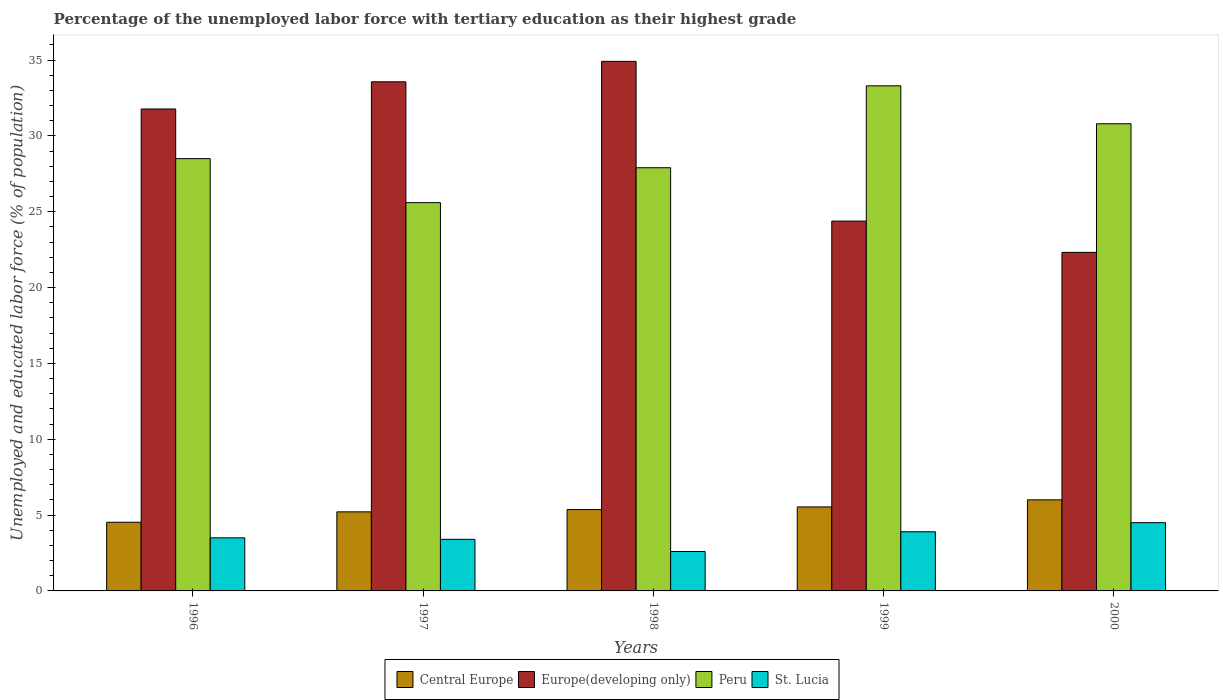In how many cases, is the number of bars for a given year not equal to the number of legend labels?
Your answer should be very brief. 0. What is the percentage of the unemployed labor force with tertiary education in Peru in 1998?
Your answer should be compact. 27.9. Across all years, what is the maximum percentage of the unemployed labor force with tertiary education in Central Europe?
Your answer should be compact. 6.01. Across all years, what is the minimum percentage of the unemployed labor force with tertiary education in Central Europe?
Offer a terse response. 4.53. In which year was the percentage of the unemployed labor force with tertiary education in Central Europe maximum?
Your answer should be compact. 2000. In which year was the percentage of the unemployed labor force with tertiary education in Peru minimum?
Your response must be concise. 1997. What is the total percentage of the unemployed labor force with tertiary education in Europe(developing only) in the graph?
Make the answer very short. 146.96. What is the difference between the percentage of the unemployed labor force with tertiary education in Europe(developing only) in 1996 and that in 1998?
Ensure brevity in your answer.  -3.14. What is the difference between the percentage of the unemployed labor force with tertiary education in Central Europe in 1997 and the percentage of the unemployed labor force with tertiary education in Peru in 1999?
Provide a succinct answer. -28.09. What is the average percentage of the unemployed labor force with tertiary education in Europe(developing only) per year?
Provide a short and direct response. 29.39. In the year 2000, what is the difference between the percentage of the unemployed labor force with tertiary education in Peru and percentage of the unemployed labor force with tertiary education in Europe(developing only)?
Provide a succinct answer. 8.48. What is the ratio of the percentage of the unemployed labor force with tertiary education in St. Lucia in 1996 to that in 2000?
Keep it short and to the point. 0.78. Is the difference between the percentage of the unemployed labor force with tertiary education in Peru in 1997 and 1998 greater than the difference between the percentage of the unemployed labor force with tertiary education in Europe(developing only) in 1997 and 1998?
Make the answer very short. No. What is the difference between the highest and the second highest percentage of the unemployed labor force with tertiary education in Europe(developing only)?
Provide a succinct answer. 1.35. What is the difference between the highest and the lowest percentage of the unemployed labor force with tertiary education in Peru?
Offer a very short reply. 7.7. In how many years, is the percentage of the unemployed labor force with tertiary education in Peru greater than the average percentage of the unemployed labor force with tertiary education in Peru taken over all years?
Your answer should be very brief. 2. Is the sum of the percentage of the unemployed labor force with tertiary education in Peru in 1996 and 1998 greater than the maximum percentage of the unemployed labor force with tertiary education in St. Lucia across all years?
Ensure brevity in your answer.  Yes. What does the 2nd bar from the left in 1998 represents?
Make the answer very short. Europe(developing only). What does the 4th bar from the right in 1996 represents?
Provide a succinct answer. Central Europe. Are all the bars in the graph horizontal?
Offer a very short reply. No. What is the difference between two consecutive major ticks on the Y-axis?
Provide a short and direct response. 5. Are the values on the major ticks of Y-axis written in scientific E-notation?
Make the answer very short. No. Does the graph contain any zero values?
Provide a succinct answer. No. How many legend labels are there?
Offer a terse response. 4. How are the legend labels stacked?
Your answer should be very brief. Horizontal. What is the title of the graph?
Your response must be concise. Percentage of the unemployed labor force with tertiary education as their highest grade. What is the label or title of the Y-axis?
Keep it short and to the point. Unemployed and educated labor force (% of population). What is the Unemployed and educated labor force (% of population) in Central Europe in 1996?
Provide a succinct answer. 4.53. What is the Unemployed and educated labor force (% of population) in Europe(developing only) in 1996?
Your answer should be compact. 31.77. What is the Unemployed and educated labor force (% of population) in Central Europe in 1997?
Offer a very short reply. 5.21. What is the Unemployed and educated labor force (% of population) in Europe(developing only) in 1997?
Keep it short and to the point. 33.57. What is the Unemployed and educated labor force (% of population) in Peru in 1997?
Provide a short and direct response. 25.6. What is the Unemployed and educated labor force (% of population) in St. Lucia in 1997?
Your response must be concise. 3.4. What is the Unemployed and educated labor force (% of population) of Central Europe in 1998?
Provide a short and direct response. 5.36. What is the Unemployed and educated labor force (% of population) of Europe(developing only) in 1998?
Provide a short and direct response. 34.91. What is the Unemployed and educated labor force (% of population) of Peru in 1998?
Offer a very short reply. 27.9. What is the Unemployed and educated labor force (% of population) in St. Lucia in 1998?
Offer a very short reply. 2.6. What is the Unemployed and educated labor force (% of population) in Central Europe in 1999?
Provide a short and direct response. 5.54. What is the Unemployed and educated labor force (% of population) in Europe(developing only) in 1999?
Ensure brevity in your answer.  24.38. What is the Unemployed and educated labor force (% of population) of Peru in 1999?
Offer a terse response. 33.3. What is the Unemployed and educated labor force (% of population) of St. Lucia in 1999?
Your answer should be compact. 3.9. What is the Unemployed and educated labor force (% of population) in Central Europe in 2000?
Offer a very short reply. 6.01. What is the Unemployed and educated labor force (% of population) of Europe(developing only) in 2000?
Provide a succinct answer. 22.32. What is the Unemployed and educated labor force (% of population) of Peru in 2000?
Offer a terse response. 30.8. What is the Unemployed and educated labor force (% of population) of St. Lucia in 2000?
Your response must be concise. 4.5. Across all years, what is the maximum Unemployed and educated labor force (% of population) in Central Europe?
Provide a succinct answer. 6.01. Across all years, what is the maximum Unemployed and educated labor force (% of population) of Europe(developing only)?
Your answer should be compact. 34.91. Across all years, what is the maximum Unemployed and educated labor force (% of population) of Peru?
Your answer should be compact. 33.3. Across all years, what is the maximum Unemployed and educated labor force (% of population) of St. Lucia?
Keep it short and to the point. 4.5. Across all years, what is the minimum Unemployed and educated labor force (% of population) of Central Europe?
Keep it short and to the point. 4.53. Across all years, what is the minimum Unemployed and educated labor force (% of population) of Europe(developing only)?
Ensure brevity in your answer.  22.32. Across all years, what is the minimum Unemployed and educated labor force (% of population) of Peru?
Provide a succinct answer. 25.6. Across all years, what is the minimum Unemployed and educated labor force (% of population) in St. Lucia?
Provide a short and direct response. 2.6. What is the total Unemployed and educated labor force (% of population) in Central Europe in the graph?
Make the answer very short. 26.65. What is the total Unemployed and educated labor force (% of population) of Europe(developing only) in the graph?
Your answer should be very brief. 146.96. What is the total Unemployed and educated labor force (% of population) in Peru in the graph?
Provide a succinct answer. 146.1. What is the difference between the Unemployed and educated labor force (% of population) in Central Europe in 1996 and that in 1997?
Your answer should be compact. -0.69. What is the difference between the Unemployed and educated labor force (% of population) in Europe(developing only) in 1996 and that in 1997?
Your response must be concise. -1.79. What is the difference between the Unemployed and educated labor force (% of population) of St. Lucia in 1996 and that in 1997?
Provide a short and direct response. 0.1. What is the difference between the Unemployed and educated labor force (% of population) of Central Europe in 1996 and that in 1998?
Your response must be concise. -0.84. What is the difference between the Unemployed and educated labor force (% of population) in Europe(developing only) in 1996 and that in 1998?
Offer a terse response. -3.14. What is the difference between the Unemployed and educated labor force (% of population) in Central Europe in 1996 and that in 1999?
Provide a succinct answer. -1.01. What is the difference between the Unemployed and educated labor force (% of population) of Europe(developing only) in 1996 and that in 1999?
Offer a very short reply. 7.39. What is the difference between the Unemployed and educated labor force (% of population) in St. Lucia in 1996 and that in 1999?
Offer a terse response. -0.4. What is the difference between the Unemployed and educated labor force (% of population) in Central Europe in 1996 and that in 2000?
Give a very brief answer. -1.48. What is the difference between the Unemployed and educated labor force (% of population) in Europe(developing only) in 1996 and that in 2000?
Make the answer very short. 9.45. What is the difference between the Unemployed and educated labor force (% of population) of Peru in 1996 and that in 2000?
Offer a very short reply. -2.3. What is the difference between the Unemployed and educated labor force (% of population) of St. Lucia in 1996 and that in 2000?
Offer a very short reply. -1. What is the difference between the Unemployed and educated labor force (% of population) of Central Europe in 1997 and that in 1998?
Keep it short and to the point. -0.15. What is the difference between the Unemployed and educated labor force (% of population) in Europe(developing only) in 1997 and that in 1998?
Provide a short and direct response. -1.35. What is the difference between the Unemployed and educated labor force (% of population) in Peru in 1997 and that in 1998?
Ensure brevity in your answer.  -2.3. What is the difference between the Unemployed and educated labor force (% of population) of Central Europe in 1997 and that in 1999?
Give a very brief answer. -0.33. What is the difference between the Unemployed and educated labor force (% of population) in Europe(developing only) in 1997 and that in 1999?
Give a very brief answer. 9.18. What is the difference between the Unemployed and educated labor force (% of population) of St. Lucia in 1997 and that in 1999?
Offer a very short reply. -0.5. What is the difference between the Unemployed and educated labor force (% of population) in Central Europe in 1997 and that in 2000?
Make the answer very short. -0.79. What is the difference between the Unemployed and educated labor force (% of population) in Europe(developing only) in 1997 and that in 2000?
Make the answer very short. 11.25. What is the difference between the Unemployed and educated labor force (% of population) of Peru in 1997 and that in 2000?
Make the answer very short. -5.2. What is the difference between the Unemployed and educated labor force (% of population) of Central Europe in 1998 and that in 1999?
Provide a succinct answer. -0.18. What is the difference between the Unemployed and educated labor force (% of population) of Europe(developing only) in 1998 and that in 1999?
Your response must be concise. 10.53. What is the difference between the Unemployed and educated labor force (% of population) of Peru in 1998 and that in 1999?
Make the answer very short. -5.4. What is the difference between the Unemployed and educated labor force (% of population) of St. Lucia in 1998 and that in 1999?
Offer a very short reply. -1.3. What is the difference between the Unemployed and educated labor force (% of population) in Central Europe in 1998 and that in 2000?
Your answer should be compact. -0.64. What is the difference between the Unemployed and educated labor force (% of population) of Europe(developing only) in 1998 and that in 2000?
Your response must be concise. 12.59. What is the difference between the Unemployed and educated labor force (% of population) in Peru in 1998 and that in 2000?
Your response must be concise. -2.9. What is the difference between the Unemployed and educated labor force (% of population) in Central Europe in 1999 and that in 2000?
Ensure brevity in your answer.  -0.47. What is the difference between the Unemployed and educated labor force (% of population) of Europe(developing only) in 1999 and that in 2000?
Offer a terse response. 2.06. What is the difference between the Unemployed and educated labor force (% of population) in Central Europe in 1996 and the Unemployed and educated labor force (% of population) in Europe(developing only) in 1997?
Give a very brief answer. -29.04. What is the difference between the Unemployed and educated labor force (% of population) of Central Europe in 1996 and the Unemployed and educated labor force (% of population) of Peru in 1997?
Keep it short and to the point. -21.07. What is the difference between the Unemployed and educated labor force (% of population) in Central Europe in 1996 and the Unemployed and educated labor force (% of population) in St. Lucia in 1997?
Keep it short and to the point. 1.13. What is the difference between the Unemployed and educated labor force (% of population) in Europe(developing only) in 1996 and the Unemployed and educated labor force (% of population) in Peru in 1997?
Provide a short and direct response. 6.17. What is the difference between the Unemployed and educated labor force (% of population) of Europe(developing only) in 1996 and the Unemployed and educated labor force (% of population) of St. Lucia in 1997?
Provide a succinct answer. 28.37. What is the difference between the Unemployed and educated labor force (% of population) of Peru in 1996 and the Unemployed and educated labor force (% of population) of St. Lucia in 1997?
Offer a terse response. 25.1. What is the difference between the Unemployed and educated labor force (% of population) in Central Europe in 1996 and the Unemployed and educated labor force (% of population) in Europe(developing only) in 1998?
Offer a very short reply. -30.39. What is the difference between the Unemployed and educated labor force (% of population) in Central Europe in 1996 and the Unemployed and educated labor force (% of population) in Peru in 1998?
Offer a terse response. -23.37. What is the difference between the Unemployed and educated labor force (% of population) of Central Europe in 1996 and the Unemployed and educated labor force (% of population) of St. Lucia in 1998?
Give a very brief answer. 1.93. What is the difference between the Unemployed and educated labor force (% of population) in Europe(developing only) in 1996 and the Unemployed and educated labor force (% of population) in Peru in 1998?
Your response must be concise. 3.87. What is the difference between the Unemployed and educated labor force (% of population) in Europe(developing only) in 1996 and the Unemployed and educated labor force (% of population) in St. Lucia in 1998?
Provide a succinct answer. 29.17. What is the difference between the Unemployed and educated labor force (% of population) in Peru in 1996 and the Unemployed and educated labor force (% of population) in St. Lucia in 1998?
Make the answer very short. 25.9. What is the difference between the Unemployed and educated labor force (% of population) in Central Europe in 1996 and the Unemployed and educated labor force (% of population) in Europe(developing only) in 1999?
Give a very brief answer. -19.86. What is the difference between the Unemployed and educated labor force (% of population) in Central Europe in 1996 and the Unemployed and educated labor force (% of population) in Peru in 1999?
Provide a succinct answer. -28.77. What is the difference between the Unemployed and educated labor force (% of population) in Central Europe in 1996 and the Unemployed and educated labor force (% of population) in St. Lucia in 1999?
Provide a short and direct response. 0.63. What is the difference between the Unemployed and educated labor force (% of population) of Europe(developing only) in 1996 and the Unemployed and educated labor force (% of population) of Peru in 1999?
Provide a short and direct response. -1.53. What is the difference between the Unemployed and educated labor force (% of population) of Europe(developing only) in 1996 and the Unemployed and educated labor force (% of population) of St. Lucia in 1999?
Provide a short and direct response. 27.87. What is the difference between the Unemployed and educated labor force (% of population) of Peru in 1996 and the Unemployed and educated labor force (% of population) of St. Lucia in 1999?
Offer a very short reply. 24.6. What is the difference between the Unemployed and educated labor force (% of population) of Central Europe in 1996 and the Unemployed and educated labor force (% of population) of Europe(developing only) in 2000?
Ensure brevity in your answer.  -17.79. What is the difference between the Unemployed and educated labor force (% of population) of Central Europe in 1996 and the Unemployed and educated labor force (% of population) of Peru in 2000?
Your response must be concise. -26.27. What is the difference between the Unemployed and educated labor force (% of population) in Central Europe in 1996 and the Unemployed and educated labor force (% of population) in St. Lucia in 2000?
Your response must be concise. 0.03. What is the difference between the Unemployed and educated labor force (% of population) in Europe(developing only) in 1996 and the Unemployed and educated labor force (% of population) in Peru in 2000?
Your answer should be compact. 0.97. What is the difference between the Unemployed and educated labor force (% of population) of Europe(developing only) in 1996 and the Unemployed and educated labor force (% of population) of St. Lucia in 2000?
Keep it short and to the point. 27.27. What is the difference between the Unemployed and educated labor force (% of population) of Central Europe in 1997 and the Unemployed and educated labor force (% of population) of Europe(developing only) in 1998?
Ensure brevity in your answer.  -29.7. What is the difference between the Unemployed and educated labor force (% of population) in Central Europe in 1997 and the Unemployed and educated labor force (% of population) in Peru in 1998?
Your response must be concise. -22.69. What is the difference between the Unemployed and educated labor force (% of population) of Central Europe in 1997 and the Unemployed and educated labor force (% of population) of St. Lucia in 1998?
Your answer should be very brief. 2.61. What is the difference between the Unemployed and educated labor force (% of population) in Europe(developing only) in 1997 and the Unemployed and educated labor force (% of population) in Peru in 1998?
Your response must be concise. 5.67. What is the difference between the Unemployed and educated labor force (% of population) in Europe(developing only) in 1997 and the Unemployed and educated labor force (% of population) in St. Lucia in 1998?
Give a very brief answer. 30.97. What is the difference between the Unemployed and educated labor force (% of population) of Peru in 1997 and the Unemployed and educated labor force (% of population) of St. Lucia in 1998?
Your response must be concise. 23. What is the difference between the Unemployed and educated labor force (% of population) in Central Europe in 1997 and the Unemployed and educated labor force (% of population) in Europe(developing only) in 1999?
Offer a very short reply. -19.17. What is the difference between the Unemployed and educated labor force (% of population) of Central Europe in 1997 and the Unemployed and educated labor force (% of population) of Peru in 1999?
Give a very brief answer. -28.09. What is the difference between the Unemployed and educated labor force (% of population) of Central Europe in 1997 and the Unemployed and educated labor force (% of population) of St. Lucia in 1999?
Make the answer very short. 1.31. What is the difference between the Unemployed and educated labor force (% of population) in Europe(developing only) in 1997 and the Unemployed and educated labor force (% of population) in Peru in 1999?
Make the answer very short. 0.27. What is the difference between the Unemployed and educated labor force (% of population) of Europe(developing only) in 1997 and the Unemployed and educated labor force (% of population) of St. Lucia in 1999?
Offer a terse response. 29.67. What is the difference between the Unemployed and educated labor force (% of population) of Peru in 1997 and the Unemployed and educated labor force (% of population) of St. Lucia in 1999?
Provide a succinct answer. 21.7. What is the difference between the Unemployed and educated labor force (% of population) in Central Europe in 1997 and the Unemployed and educated labor force (% of population) in Europe(developing only) in 2000?
Offer a very short reply. -17.11. What is the difference between the Unemployed and educated labor force (% of population) in Central Europe in 1997 and the Unemployed and educated labor force (% of population) in Peru in 2000?
Your response must be concise. -25.59. What is the difference between the Unemployed and educated labor force (% of population) of Central Europe in 1997 and the Unemployed and educated labor force (% of population) of St. Lucia in 2000?
Offer a very short reply. 0.71. What is the difference between the Unemployed and educated labor force (% of population) of Europe(developing only) in 1997 and the Unemployed and educated labor force (% of population) of Peru in 2000?
Ensure brevity in your answer.  2.77. What is the difference between the Unemployed and educated labor force (% of population) in Europe(developing only) in 1997 and the Unemployed and educated labor force (% of population) in St. Lucia in 2000?
Offer a terse response. 29.07. What is the difference between the Unemployed and educated labor force (% of population) in Peru in 1997 and the Unemployed and educated labor force (% of population) in St. Lucia in 2000?
Your answer should be compact. 21.1. What is the difference between the Unemployed and educated labor force (% of population) of Central Europe in 1998 and the Unemployed and educated labor force (% of population) of Europe(developing only) in 1999?
Offer a terse response. -19.02. What is the difference between the Unemployed and educated labor force (% of population) of Central Europe in 1998 and the Unemployed and educated labor force (% of population) of Peru in 1999?
Make the answer very short. -27.94. What is the difference between the Unemployed and educated labor force (% of population) in Central Europe in 1998 and the Unemployed and educated labor force (% of population) in St. Lucia in 1999?
Keep it short and to the point. 1.46. What is the difference between the Unemployed and educated labor force (% of population) of Europe(developing only) in 1998 and the Unemployed and educated labor force (% of population) of Peru in 1999?
Give a very brief answer. 1.61. What is the difference between the Unemployed and educated labor force (% of population) of Europe(developing only) in 1998 and the Unemployed and educated labor force (% of population) of St. Lucia in 1999?
Provide a succinct answer. 31.01. What is the difference between the Unemployed and educated labor force (% of population) of Peru in 1998 and the Unemployed and educated labor force (% of population) of St. Lucia in 1999?
Keep it short and to the point. 24. What is the difference between the Unemployed and educated labor force (% of population) of Central Europe in 1998 and the Unemployed and educated labor force (% of population) of Europe(developing only) in 2000?
Provide a succinct answer. -16.96. What is the difference between the Unemployed and educated labor force (% of population) of Central Europe in 1998 and the Unemployed and educated labor force (% of population) of Peru in 2000?
Your response must be concise. -25.44. What is the difference between the Unemployed and educated labor force (% of population) of Central Europe in 1998 and the Unemployed and educated labor force (% of population) of St. Lucia in 2000?
Your answer should be compact. 0.86. What is the difference between the Unemployed and educated labor force (% of population) of Europe(developing only) in 1998 and the Unemployed and educated labor force (% of population) of Peru in 2000?
Provide a succinct answer. 4.11. What is the difference between the Unemployed and educated labor force (% of population) in Europe(developing only) in 1998 and the Unemployed and educated labor force (% of population) in St. Lucia in 2000?
Your answer should be very brief. 30.41. What is the difference between the Unemployed and educated labor force (% of population) of Peru in 1998 and the Unemployed and educated labor force (% of population) of St. Lucia in 2000?
Give a very brief answer. 23.4. What is the difference between the Unemployed and educated labor force (% of population) of Central Europe in 1999 and the Unemployed and educated labor force (% of population) of Europe(developing only) in 2000?
Provide a succinct answer. -16.78. What is the difference between the Unemployed and educated labor force (% of population) in Central Europe in 1999 and the Unemployed and educated labor force (% of population) in Peru in 2000?
Make the answer very short. -25.26. What is the difference between the Unemployed and educated labor force (% of population) in Central Europe in 1999 and the Unemployed and educated labor force (% of population) in St. Lucia in 2000?
Make the answer very short. 1.04. What is the difference between the Unemployed and educated labor force (% of population) of Europe(developing only) in 1999 and the Unemployed and educated labor force (% of population) of Peru in 2000?
Offer a very short reply. -6.42. What is the difference between the Unemployed and educated labor force (% of population) in Europe(developing only) in 1999 and the Unemployed and educated labor force (% of population) in St. Lucia in 2000?
Your answer should be very brief. 19.88. What is the difference between the Unemployed and educated labor force (% of population) in Peru in 1999 and the Unemployed and educated labor force (% of population) in St. Lucia in 2000?
Offer a very short reply. 28.8. What is the average Unemployed and educated labor force (% of population) of Central Europe per year?
Offer a very short reply. 5.33. What is the average Unemployed and educated labor force (% of population) in Europe(developing only) per year?
Provide a succinct answer. 29.39. What is the average Unemployed and educated labor force (% of population) of Peru per year?
Your response must be concise. 29.22. What is the average Unemployed and educated labor force (% of population) of St. Lucia per year?
Give a very brief answer. 3.58. In the year 1996, what is the difference between the Unemployed and educated labor force (% of population) of Central Europe and Unemployed and educated labor force (% of population) of Europe(developing only)?
Provide a short and direct response. -27.25. In the year 1996, what is the difference between the Unemployed and educated labor force (% of population) of Central Europe and Unemployed and educated labor force (% of population) of Peru?
Offer a terse response. -23.97. In the year 1996, what is the difference between the Unemployed and educated labor force (% of population) of Central Europe and Unemployed and educated labor force (% of population) of St. Lucia?
Offer a terse response. 1.03. In the year 1996, what is the difference between the Unemployed and educated labor force (% of population) of Europe(developing only) and Unemployed and educated labor force (% of population) of Peru?
Make the answer very short. 3.27. In the year 1996, what is the difference between the Unemployed and educated labor force (% of population) in Europe(developing only) and Unemployed and educated labor force (% of population) in St. Lucia?
Your answer should be very brief. 28.27. In the year 1996, what is the difference between the Unemployed and educated labor force (% of population) of Peru and Unemployed and educated labor force (% of population) of St. Lucia?
Offer a terse response. 25. In the year 1997, what is the difference between the Unemployed and educated labor force (% of population) in Central Europe and Unemployed and educated labor force (% of population) in Europe(developing only)?
Offer a terse response. -28.35. In the year 1997, what is the difference between the Unemployed and educated labor force (% of population) of Central Europe and Unemployed and educated labor force (% of population) of Peru?
Make the answer very short. -20.39. In the year 1997, what is the difference between the Unemployed and educated labor force (% of population) in Central Europe and Unemployed and educated labor force (% of population) in St. Lucia?
Offer a terse response. 1.81. In the year 1997, what is the difference between the Unemployed and educated labor force (% of population) in Europe(developing only) and Unemployed and educated labor force (% of population) in Peru?
Offer a terse response. 7.97. In the year 1997, what is the difference between the Unemployed and educated labor force (% of population) of Europe(developing only) and Unemployed and educated labor force (% of population) of St. Lucia?
Give a very brief answer. 30.17. In the year 1997, what is the difference between the Unemployed and educated labor force (% of population) in Peru and Unemployed and educated labor force (% of population) in St. Lucia?
Your answer should be compact. 22.2. In the year 1998, what is the difference between the Unemployed and educated labor force (% of population) of Central Europe and Unemployed and educated labor force (% of population) of Europe(developing only)?
Your answer should be very brief. -29.55. In the year 1998, what is the difference between the Unemployed and educated labor force (% of population) of Central Europe and Unemployed and educated labor force (% of population) of Peru?
Make the answer very short. -22.54. In the year 1998, what is the difference between the Unemployed and educated labor force (% of population) in Central Europe and Unemployed and educated labor force (% of population) in St. Lucia?
Offer a very short reply. 2.76. In the year 1998, what is the difference between the Unemployed and educated labor force (% of population) in Europe(developing only) and Unemployed and educated labor force (% of population) in Peru?
Offer a very short reply. 7.01. In the year 1998, what is the difference between the Unemployed and educated labor force (% of population) of Europe(developing only) and Unemployed and educated labor force (% of population) of St. Lucia?
Your answer should be compact. 32.31. In the year 1998, what is the difference between the Unemployed and educated labor force (% of population) in Peru and Unemployed and educated labor force (% of population) in St. Lucia?
Your answer should be very brief. 25.3. In the year 1999, what is the difference between the Unemployed and educated labor force (% of population) in Central Europe and Unemployed and educated labor force (% of population) in Europe(developing only)?
Provide a short and direct response. -18.84. In the year 1999, what is the difference between the Unemployed and educated labor force (% of population) in Central Europe and Unemployed and educated labor force (% of population) in Peru?
Your response must be concise. -27.76. In the year 1999, what is the difference between the Unemployed and educated labor force (% of population) in Central Europe and Unemployed and educated labor force (% of population) in St. Lucia?
Your response must be concise. 1.64. In the year 1999, what is the difference between the Unemployed and educated labor force (% of population) in Europe(developing only) and Unemployed and educated labor force (% of population) in Peru?
Offer a terse response. -8.92. In the year 1999, what is the difference between the Unemployed and educated labor force (% of population) in Europe(developing only) and Unemployed and educated labor force (% of population) in St. Lucia?
Provide a succinct answer. 20.48. In the year 1999, what is the difference between the Unemployed and educated labor force (% of population) in Peru and Unemployed and educated labor force (% of population) in St. Lucia?
Your answer should be very brief. 29.4. In the year 2000, what is the difference between the Unemployed and educated labor force (% of population) in Central Europe and Unemployed and educated labor force (% of population) in Europe(developing only)?
Your response must be concise. -16.32. In the year 2000, what is the difference between the Unemployed and educated labor force (% of population) in Central Europe and Unemployed and educated labor force (% of population) in Peru?
Make the answer very short. -24.8. In the year 2000, what is the difference between the Unemployed and educated labor force (% of population) of Central Europe and Unemployed and educated labor force (% of population) of St. Lucia?
Provide a succinct answer. 1.5. In the year 2000, what is the difference between the Unemployed and educated labor force (% of population) of Europe(developing only) and Unemployed and educated labor force (% of population) of Peru?
Give a very brief answer. -8.48. In the year 2000, what is the difference between the Unemployed and educated labor force (% of population) of Europe(developing only) and Unemployed and educated labor force (% of population) of St. Lucia?
Your response must be concise. 17.82. In the year 2000, what is the difference between the Unemployed and educated labor force (% of population) in Peru and Unemployed and educated labor force (% of population) in St. Lucia?
Your response must be concise. 26.3. What is the ratio of the Unemployed and educated labor force (% of population) of Central Europe in 1996 to that in 1997?
Your answer should be compact. 0.87. What is the ratio of the Unemployed and educated labor force (% of population) of Europe(developing only) in 1996 to that in 1997?
Ensure brevity in your answer.  0.95. What is the ratio of the Unemployed and educated labor force (% of population) in Peru in 1996 to that in 1997?
Your answer should be very brief. 1.11. What is the ratio of the Unemployed and educated labor force (% of population) of St. Lucia in 1996 to that in 1997?
Make the answer very short. 1.03. What is the ratio of the Unemployed and educated labor force (% of population) of Central Europe in 1996 to that in 1998?
Your response must be concise. 0.84. What is the ratio of the Unemployed and educated labor force (% of population) in Europe(developing only) in 1996 to that in 1998?
Your answer should be compact. 0.91. What is the ratio of the Unemployed and educated labor force (% of population) in Peru in 1996 to that in 1998?
Keep it short and to the point. 1.02. What is the ratio of the Unemployed and educated labor force (% of population) in St. Lucia in 1996 to that in 1998?
Ensure brevity in your answer.  1.35. What is the ratio of the Unemployed and educated labor force (% of population) in Central Europe in 1996 to that in 1999?
Provide a succinct answer. 0.82. What is the ratio of the Unemployed and educated labor force (% of population) of Europe(developing only) in 1996 to that in 1999?
Your response must be concise. 1.3. What is the ratio of the Unemployed and educated labor force (% of population) in Peru in 1996 to that in 1999?
Offer a terse response. 0.86. What is the ratio of the Unemployed and educated labor force (% of population) in St. Lucia in 1996 to that in 1999?
Give a very brief answer. 0.9. What is the ratio of the Unemployed and educated labor force (% of population) in Central Europe in 1996 to that in 2000?
Offer a very short reply. 0.75. What is the ratio of the Unemployed and educated labor force (% of population) of Europe(developing only) in 1996 to that in 2000?
Provide a short and direct response. 1.42. What is the ratio of the Unemployed and educated labor force (% of population) in Peru in 1996 to that in 2000?
Make the answer very short. 0.93. What is the ratio of the Unemployed and educated labor force (% of population) of St. Lucia in 1996 to that in 2000?
Your response must be concise. 0.78. What is the ratio of the Unemployed and educated labor force (% of population) in Central Europe in 1997 to that in 1998?
Ensure brevity in your answer.  0.97. What is the ratio of the Unemployed and educated labor force (% of population) of Europe(developing only) in 1997 to that in 1998?
Your answer should be very brief. 0.96. What is the ratio of the Unemployed and educated labor force (% of population) of Peru in 1997 to that in 1998?
Your answer should be compact. 0.92. What is the ratio of the Unemployed and educated labor force (% of population) in St. Lucia in 1997 to that in 1998?
Provide a succinct answer. 1.31. What is the ratio of the Unemployed and educated labor force (% of population) in Central Europe in 1997 to that in 1999?
Keep it short and to the point. 0.94. What is the ratio of the Unemployed and educated labor force (% of population) of Europe(developing only) in 1997 to that in 1999?
Your answer should be compact. 1.38. What is the ratio of the Unemployed and educated labor force (% of population) in Peru in 1997 to that in 1999?
Keep it short and to the point. 0.77. What is the ratio of the Unemployed and educated labor force (% of population) in St. Lucia in 1997 to that in 1999?
Offer a very short reply. 0.87. What is the ratio of the Unemployed and educated labor force (% of population) of Central Europe in 1997 to that in 2000?
Provide a short and direct response. 0.87. What is the ratio of the Unemployed and educated labor force (% of population) of Europe(developing only) in 1997 to that in 2000?
Your answer should be very brief. 1.5. What is the ratio of the Unemployed and educated labor force (% of population) in Peru in 1997 to that in 2000?
Provide a short and direct response. 0.83. What is the ratio of the Unemployed and educated labor force (% of population) of St. Lucia in 1997 to that in 2000?
Your answer should be compact. 0.76. What is the ratio of the Unemployed and educated labor force (% of population) of Central Europe in 1998 to that in 1999?
Ensure brevity in your answer.  0.97. What is the ratio of the Unemployed and educated labor force (% of population) of Europe(developing only) in 1998 to that in 1999?
Offer a terse response. 1.43. What is the ratio of the Unemployed and educated labor force (% of population) of Peru in 1998 to that in 1999?
Offer a terse response. 0.84. What is the ratio of the Unemployed and educated labor force (% of population) of Central Europe in 1998 to that in 2000?
Keep it short and to the point. 0.89. What is the ratio of the Unemployed and educated labor force (% of population) in Europe(developing only) in 1998 to that in 2000?
Your answer should be compact. 1.56. What is the ratio of the Unemployed and educated labor force (% of population) of Peru in 1998 to that in 2000?
Provide a short and direct response. 0.91. What is the ratio of the Unemployed and educated labor force (% of population) in St. Lucia in 1998 to that in 2000?
Your answer should be compact. 0.58. What is the ratio of the Unemployed and educated labor force (% of population) of Central Europe in 1999 to that in 2000?
Your answer should be very brief. 0.92. What is the ratio of the Unemployed and educated labor force (% of population) of Europe(developing only) in 1999 to that in 2000?
Give a very brief answer. 1.09. What is the ratio of the Unemployed and educated labor force (% of population) of Peru in 1999 to that in 2000?
Your answer should be compact. 1.08. What is the ratio of the Unemployed and educated labor force (% of population) of St. Lucia in 1999 to that in 2000?
Your answer should be very brief. 0.87. What is the difference between the highest and the second highest Unemployed and educated labor force (% of population) of Central Europe?
Offer a terse response. 0.47. What is the difference between the highest and the second highest Unemployed and educated labor force (% of population) of Europe(developing only)?
Keep it short and to the point. 1.35. What is the difference between the highest and the second highest Unemployed and educated labor force (% of population) of St. Lucia?
Give a very brief answer. 0.6. What is the difference between the highest and the lowest Unemployed and educated labor force (% of population) in Central Europe?
Your answer should be compact. 1.48. What is the difference between the highest and the lowest Unemployed and educated labor force (% of population) in Europe(developing only)?
Your answer should be very brief. 12.59. What is the difference between the highest and the lowest Unemployed and educated labor force (% of population) of Peru?
Make the answer very short. 7.7. What is the difference between the highest and the lowest Unemployed and educated labor force (% of population) of St. Lucia?
Keep it short and to the point. 1.9. 